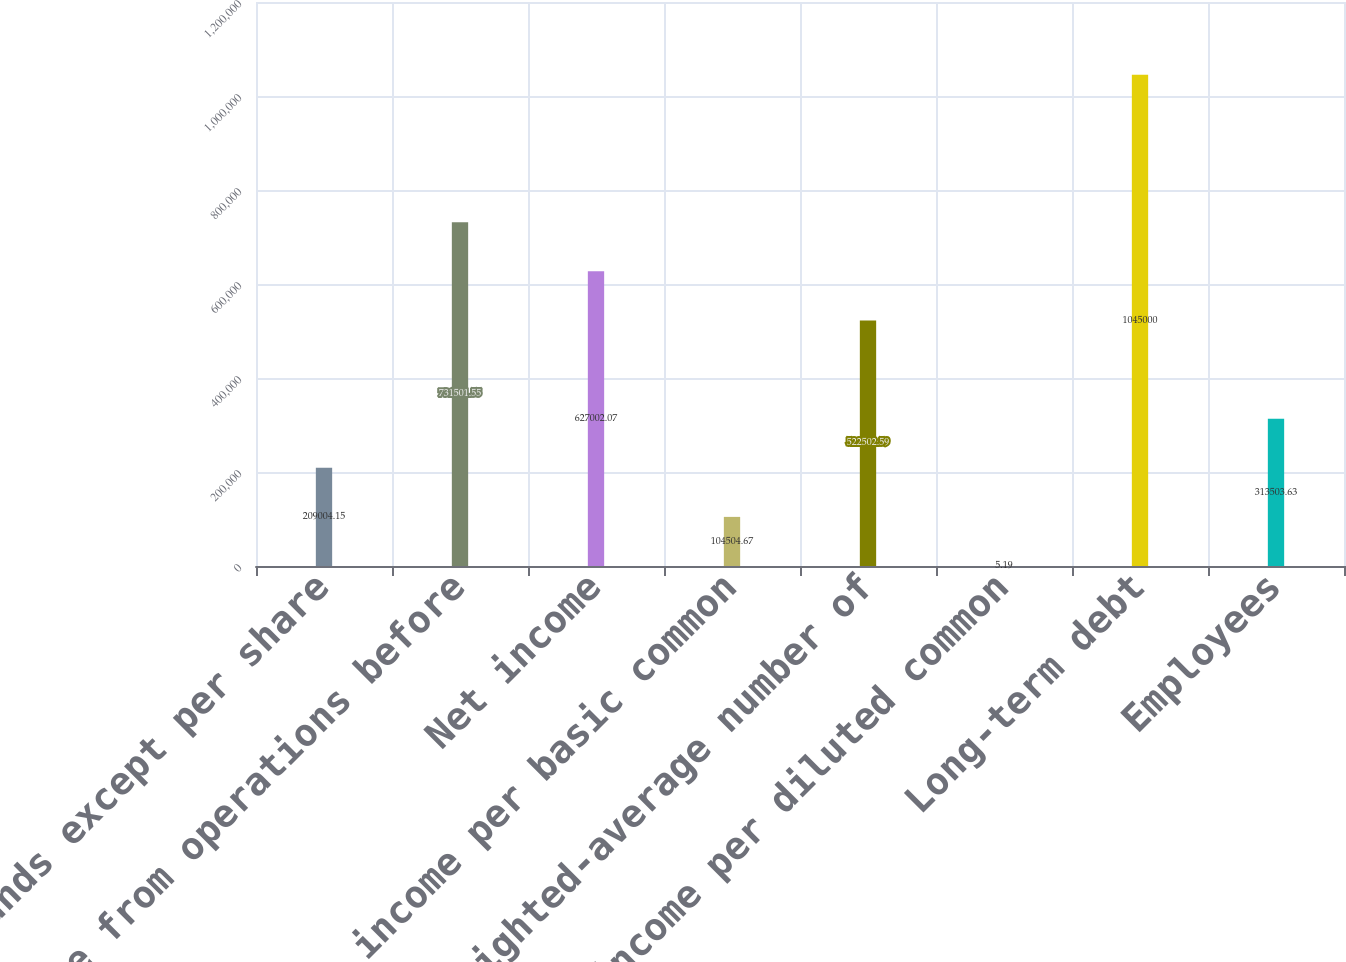Convert chart to OTSL. <chart><loc_0><loc_0><loc_500><loc_500><bar_chart><fcel>In thousands except per share<fcel>Income from operations before<fcel>Net income<fcel>Net income per basic common<fcel>Weighted-average number of<fcel>Net income per diluted common<fcel>Long-term debt<fcel>Employees<nl><fcel>209004<fcel>731502<fcel>627002<fcel>104505<fcel>522503<fcel>5.19<fcel>1.045e+06<fcel>313504<nl></chart> 